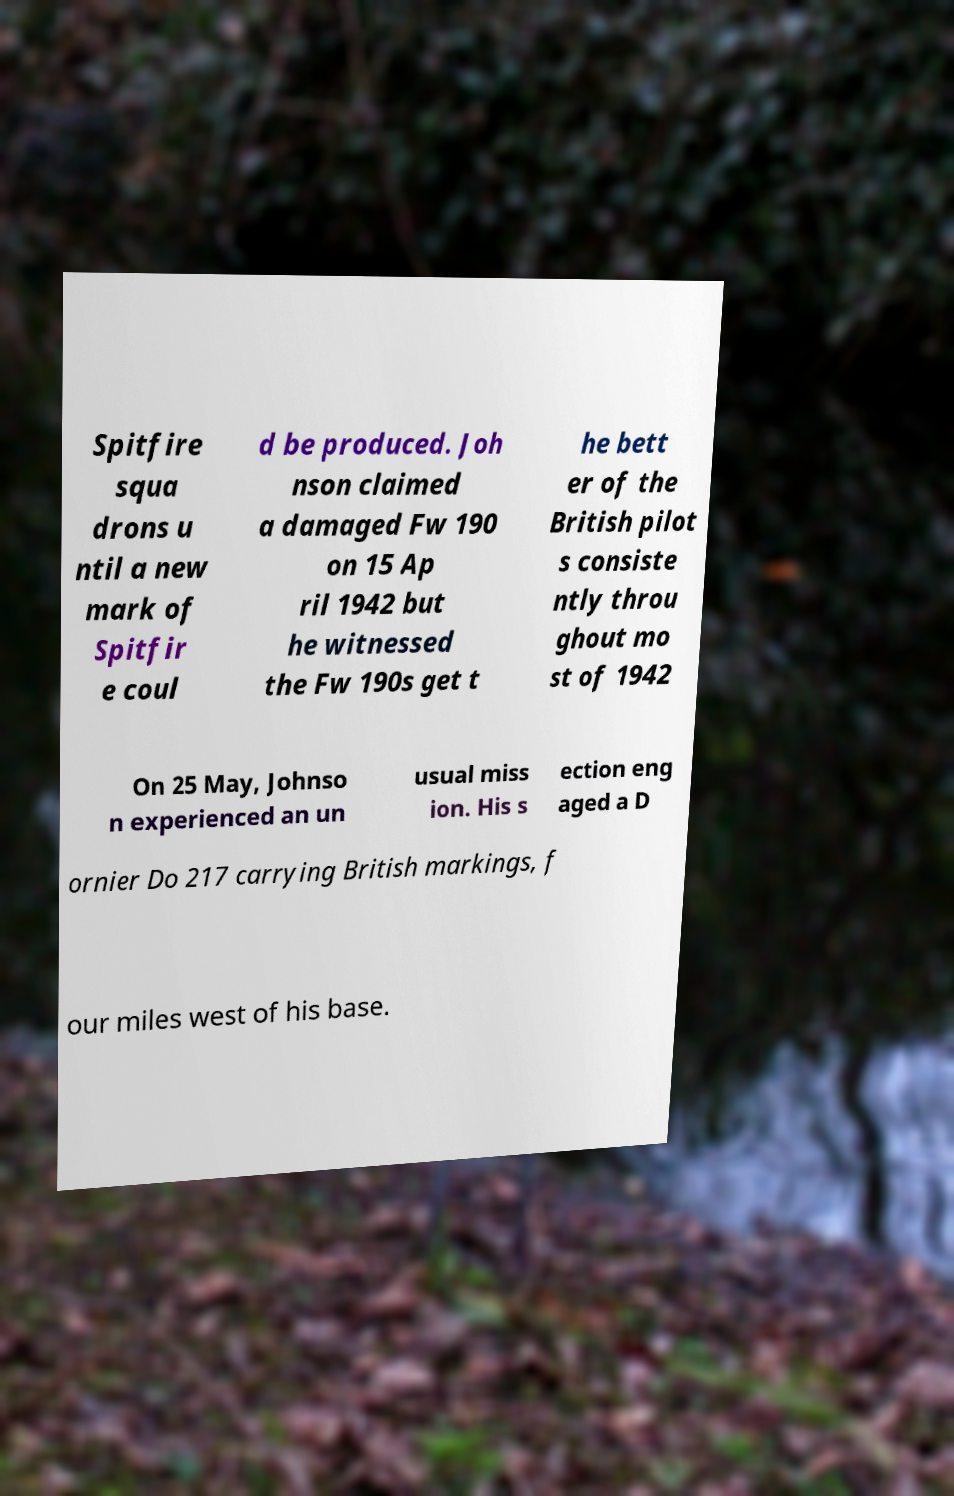What messages or text are displayed in this image? I need them in a readable, typed format. Spitfire squa drons u ntil a new mark of Spitfir e coul d be produced. Joh nson claimed a damaged Fw 190 on 15 Ap ril 1942 but he witnessed the Fw 190s get t he bett er of the British pilot s consiste ntly throu ghout mo st of 1942 On 25 May, Johnso n experienced an un usual miss ion. His s ection eng aged a D ornier Do 217 carrying British markings, f our miles west of his base. 